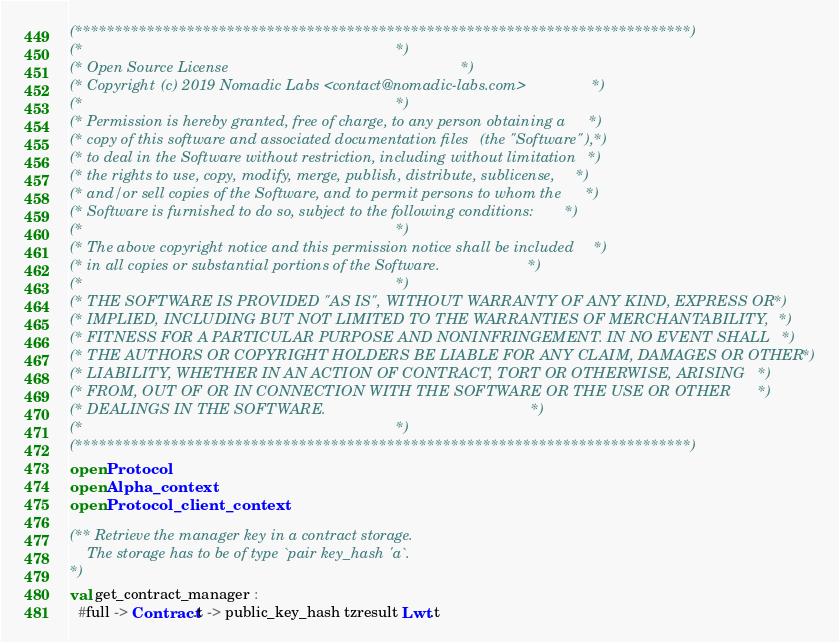<code> <loc_0><loc_0><loc_500><loc_500><_OCaml_>(*****************************************************************************)
(*                                                                           *)
(* Open Source License                                                       *)
(* Copyright (c) 2019 Nomadic Labs <contact@nomadic-labs.com>                *)
(*                                                                           *)
(* Permission is hereby granted, free of charge, to any person obtaining a   *)
(* copy of this software and associated documentation files (the "Software"),*)
(* to deal in the Software without restriction, including without limitation *)
(* the rights to use, copy, modify, merge, publish, distribute, sublicense,  *)
(* and/or sell copies of the Software, and to permit persons to whom the     *)
(* Software is furnished to do so, subject to the following conditions:      *)
(*                                                                           *)
(* The above copyright notice and this permission notice shall be included   *)
(* in all copies or substantial portions of the Software.                    *)
(*                                                                           *)
(* THE SOFTWARE IS PROVIDED "AS IS", WITHOUT WARRANTY OF ANY KIND, EXPRESS OR*)
(* IMPLIED, INCLUDING BUT NOT LIMITED TO THE WARRANTIES OF MERCHANTABILITY,  *)
(* FITNESS FOR A PARTICULAR PURPOSE AND NONINFRINGEMENT. IN NO EVENT SHALL   *)
(* THE AUTHORS OR COPYRIGHT HOLDERS BE LIABLE FOR ANY CLAIM, DAMAGES OR OTHER*)
(* LIABILITY, WHETHER IN AN ACTION OF CONTRACT, TORT OR OTHERWISE, ARISING   *)
(* FROM, OUT OF OR IN CONNECTION WITH THE SOFTWARE OR THE USE OR OTHER       *)
(* DEALINGS IN THE SOFTWARE.                                                 *)
(*                                                                           *)
(*****************************************************************************)
open Protocol
open Alpha_context
open Protocol_client_context

(** Retrieve the manager key in a contract storage.
    The storage has to be of type `pair key_hash 'a`.
*)
val get_contract_manager :
  #full -> Contract.t -> public_key_hash tzresult Lwt.t
</code> 